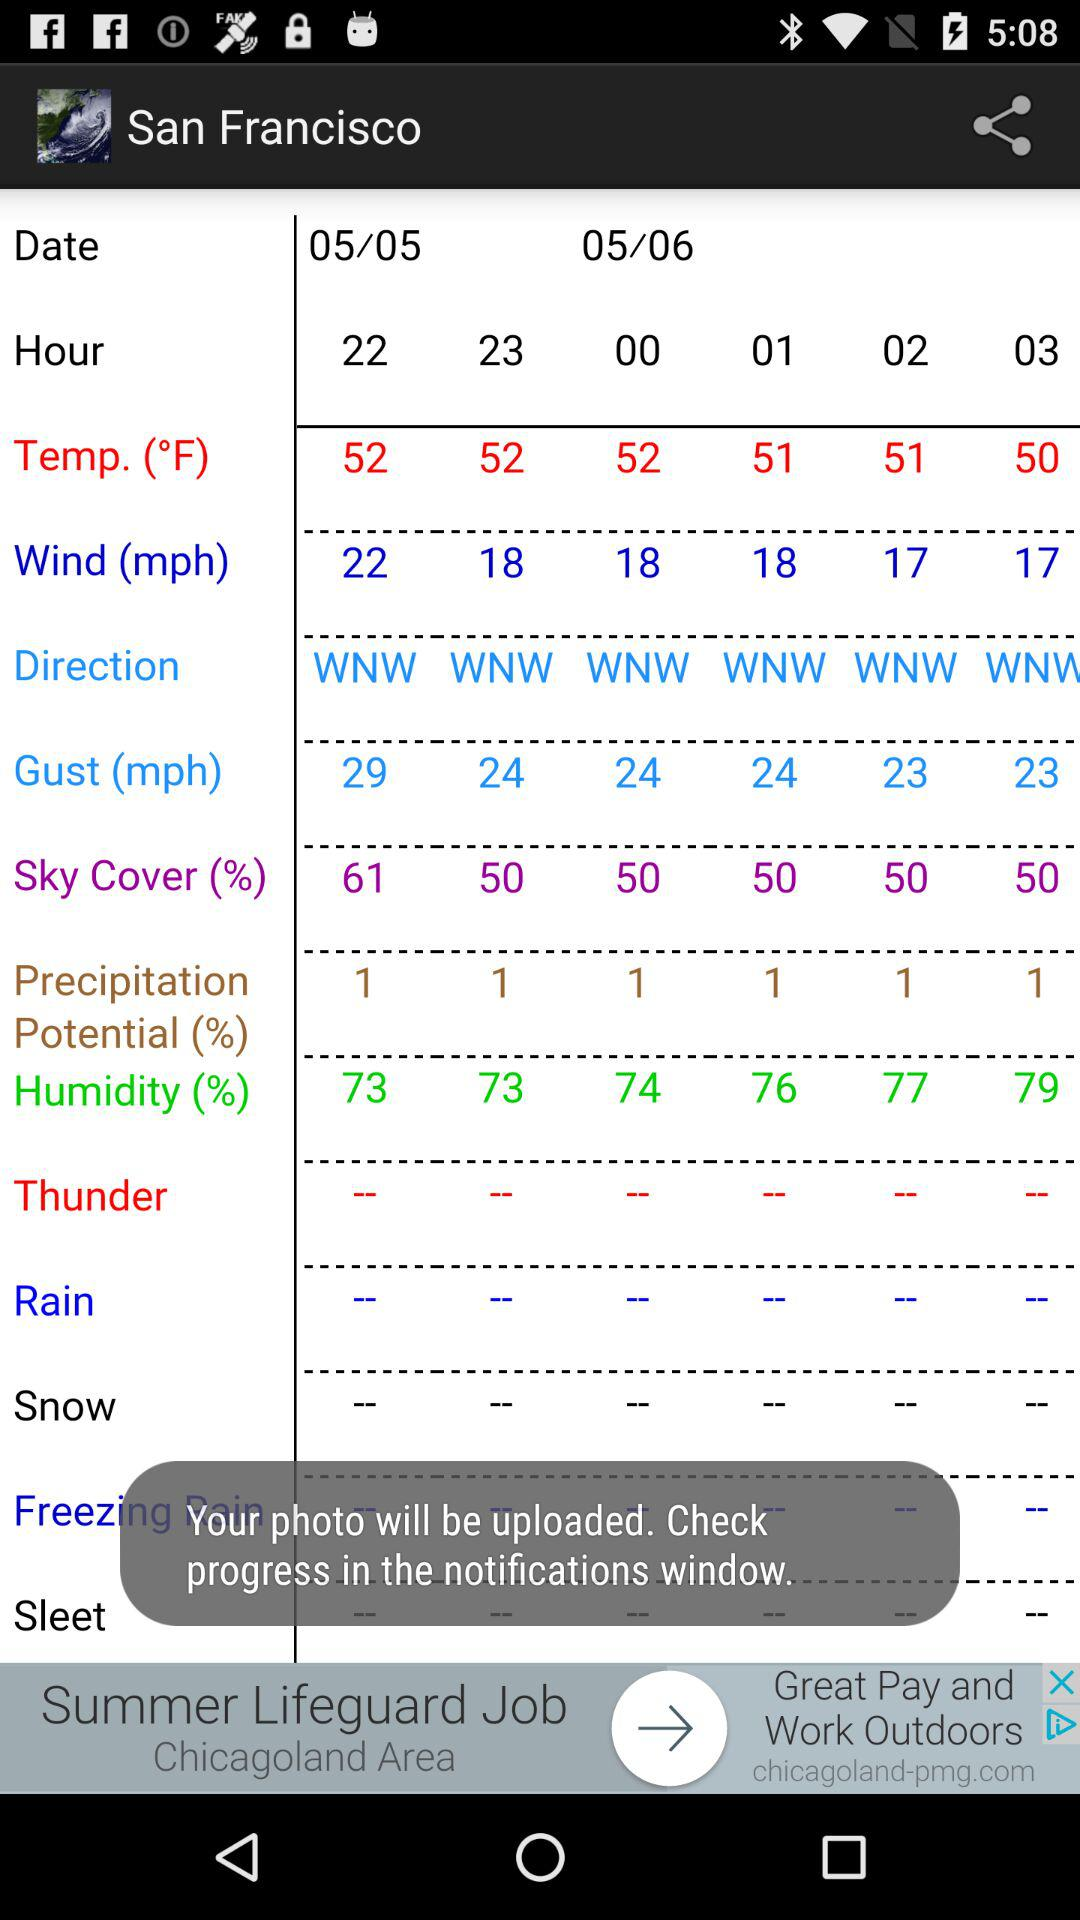What is the unit of temperature? The unit of temperature is °F. 